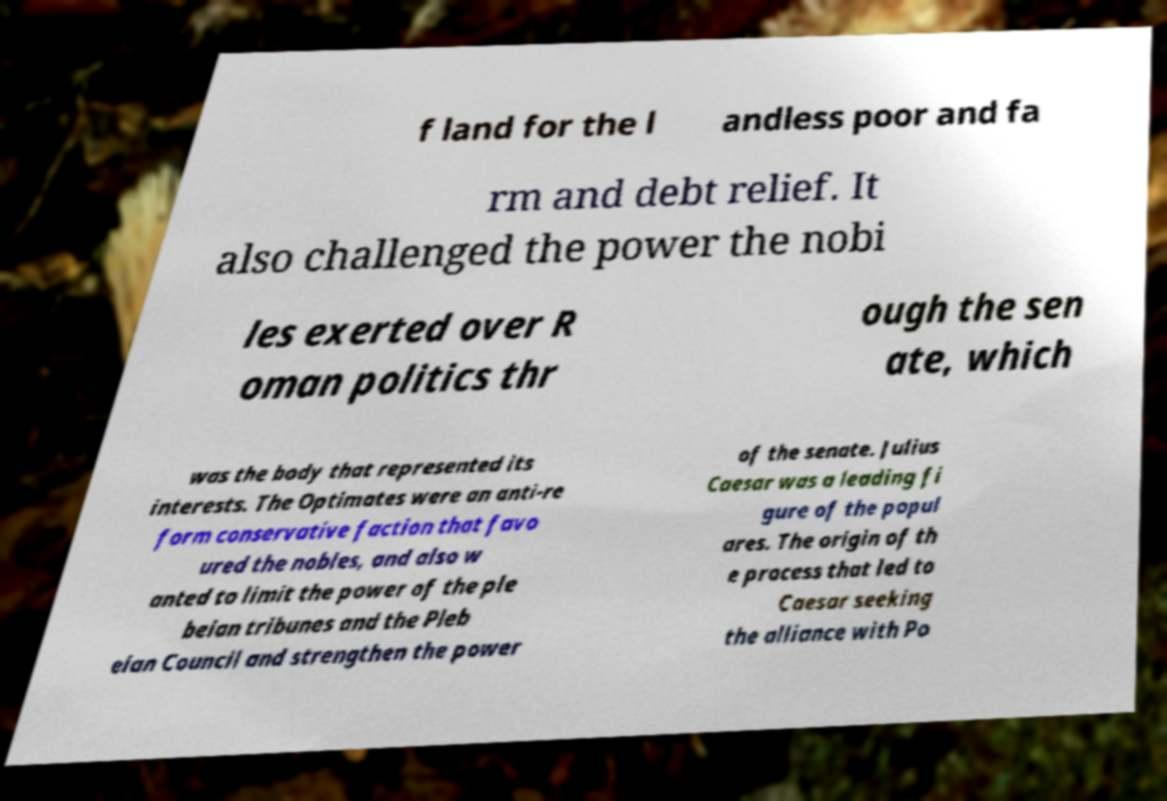I need the written content from this picture converted into text. Can you do that? f land for the l andless poor and fa rm and debt relief. It also challenged the power the nobi les exerted over R oman politics thr ough the sen ate, which was the body that represented its interests. The Optimates were an anti-re form conservative faction that favo ured the nobles, and also w anted to limit the power of the ple beian tribunes and the Pleb eian Council and strengthen the power of the senate. Julius Caesar was a leading fi gure of the popul ares. The origin of th e process that led to Caesar seeking the alliance with Po 